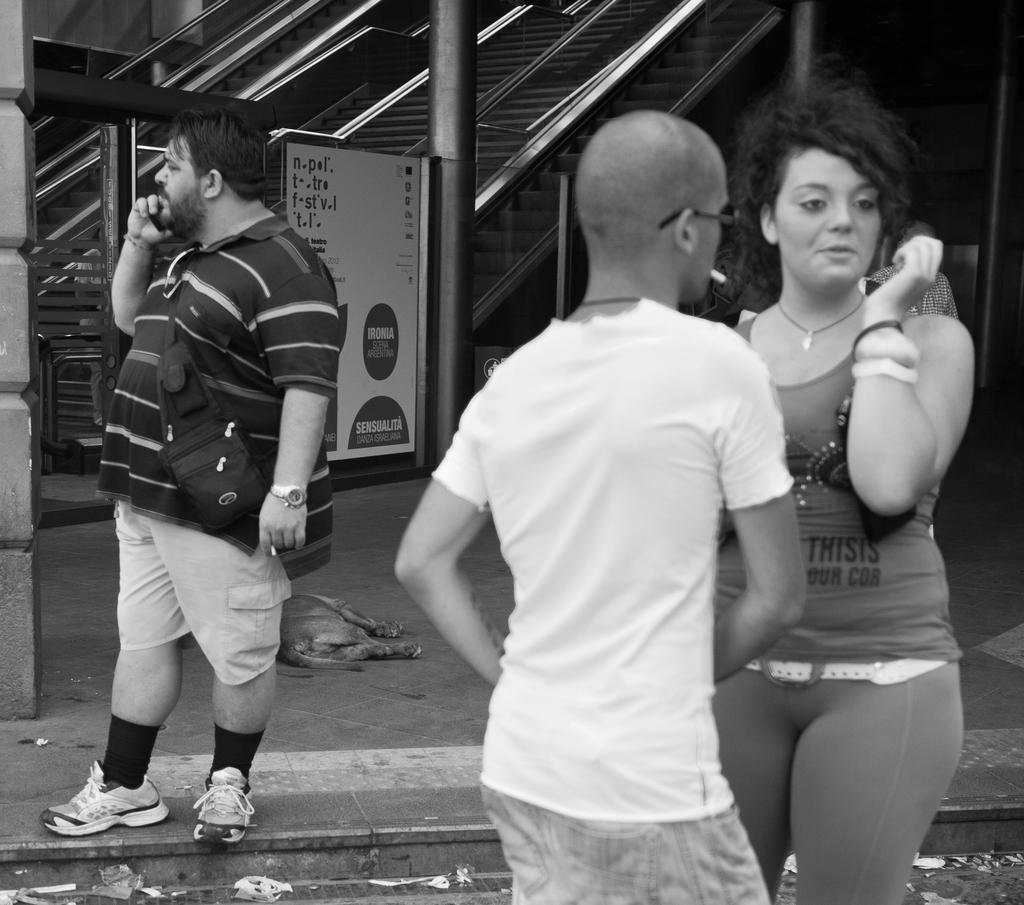Describe this image in one or two sentences. This is a black and white image. In this image, on the right side, we can see two people man and woman are standing. On the left side, we can see a man wearing a backpack is standing on the footpath. In the background, we can see a pole, hoarding with some text written on it. In the background, we can also see an escalator, at the bottom, we can see a footpath, dog. 